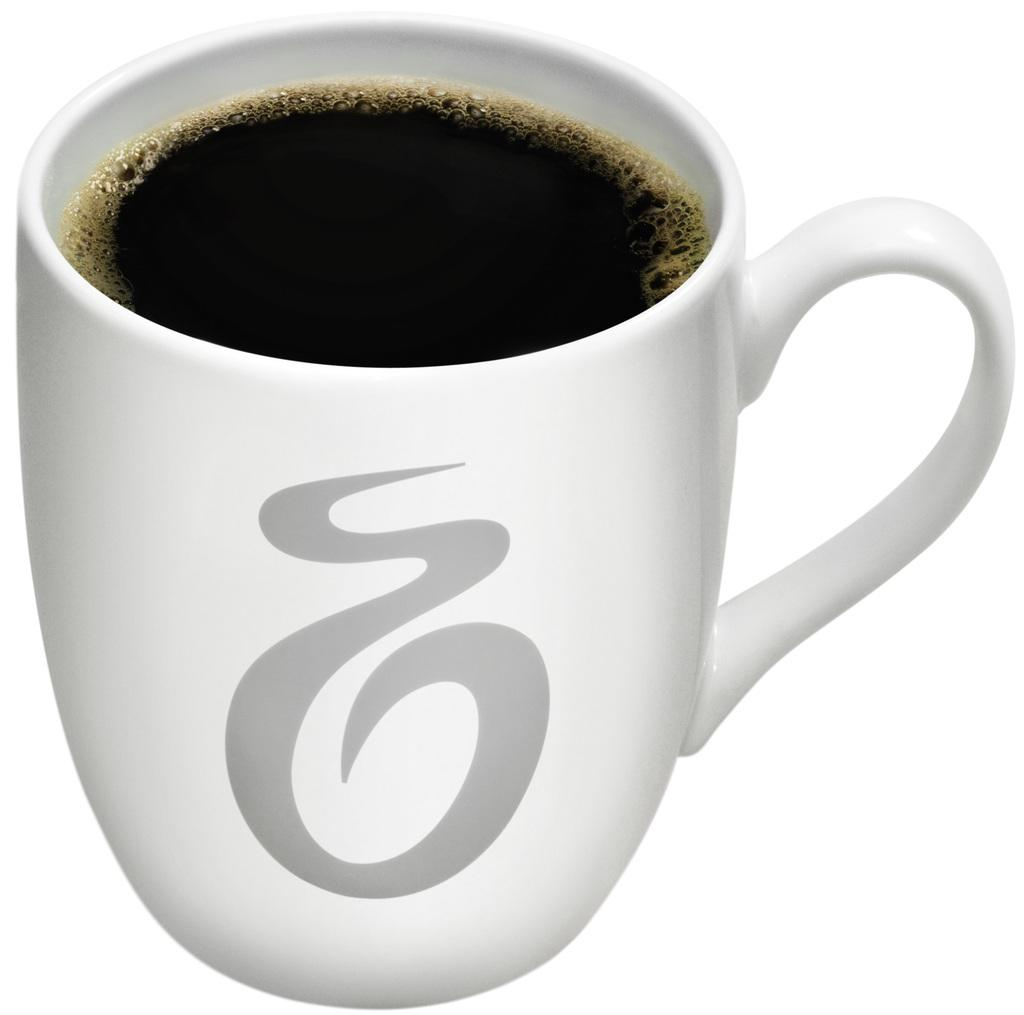What is in the image that can hold a drink? There is a cup in the image that can hold a drink. What is inside the cup? There is a drink in the cup. Can you describe the appearance of the drink? The drink has foam on it. Is there any design or symbol on the cup? Yes, there is a symbol on the cup. What color is the background of the image? The background of the image is white. Where is the writer sitting in the image? There is no writer present in the image. What type of cave can be seen in the image? There is no cave present in the image. 